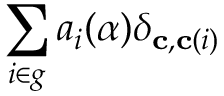Convert formula to latex. <formula><loc_0><loc_0><loc_500><loc_500>\sum _ { i \in g } a _ { i } ( \alpha ) \delta _ { c , c ( i ) }</formula> 